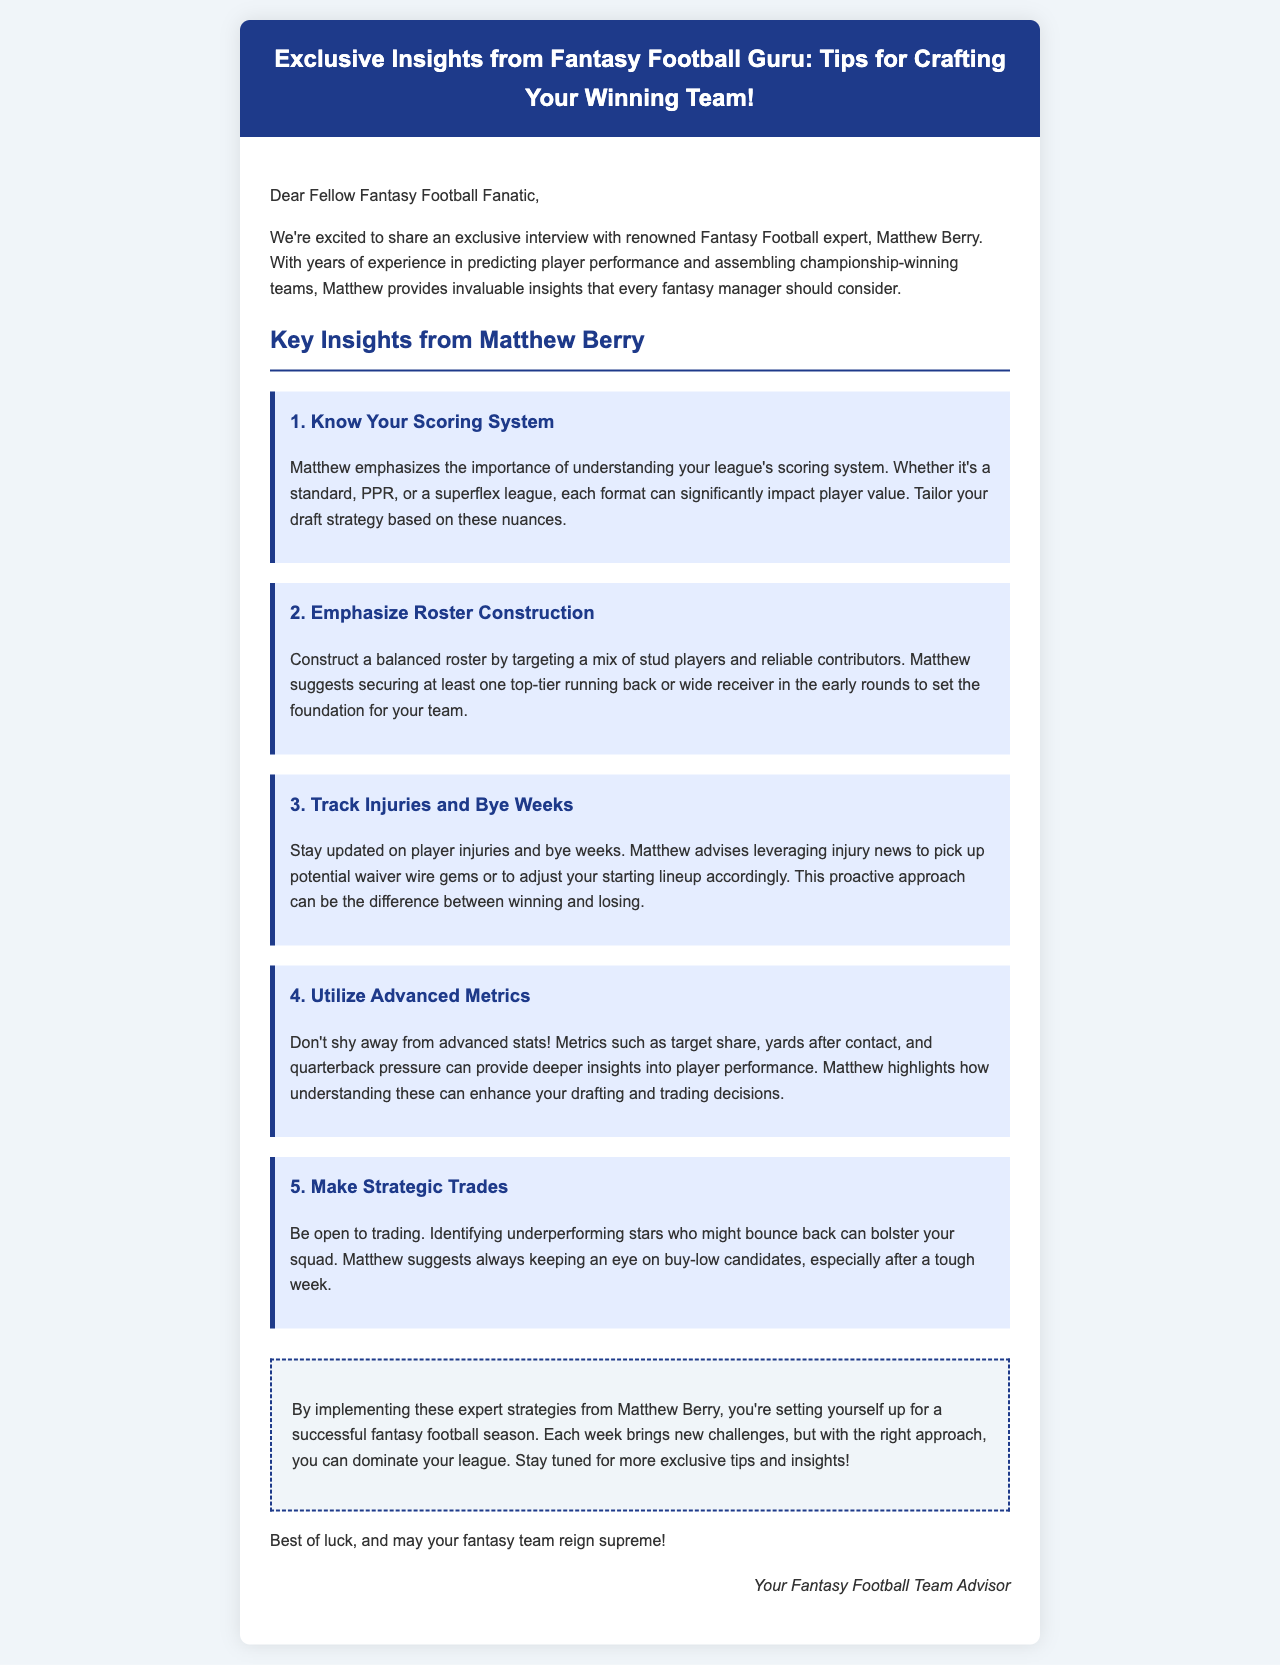What is the title of the document? The title of the document is stated in the header, which is "Exclusive Insights from Fantasy Football Guru: Tips for Crafting Your Winning Team!"
Answer: Exclusive Insights from Fantasy Football Guru: Tips for Crafting Your Winning Team! Who is the renowned Fantasy Football expert mentioned? The document introduces Matthew Berry as the renowned Fantasy Football expert providing insights.
Answer: Matthew Berry What is the first tip provided by Matthew Berry? The first tip outlined in the document emphasizes knowing your league's scoring system.
Answer: Know Your Scoring System How many tips does Matthew Berry provide in total? The document lists five specific tips given by Matthew Berry for fantasy football.
Answer: Five What should you secure in the early rounds according to Matthew Berry? Matthew suggests securing at least one top-tier running back or wide receiver in the early rounds for your team.
Answer: One top-tier running back or wide receiver What type of league formats does Matthew mention? He refers to standard, PPR, and superflex leagues when discussing the impact on player value.
Answer: Standard, PPR, superflex What does Matthew recommend tracking throughout the season? Matthew emphasizes the importance of staying updated on player injuries and bye weeks during the season.
Answer: Player injuries and bye weeks What does the conclusion suggest about the strategies provided? The conclusion indicates that implementing these expert strategies can lead to a successful fantasy football season.
Answer: Successful fantasy football season Who signed the email? The document concludes with a sign-off from "Your Fantasy Football Team Advisor."
Answer: Your Fantasy Football Team Advisor 